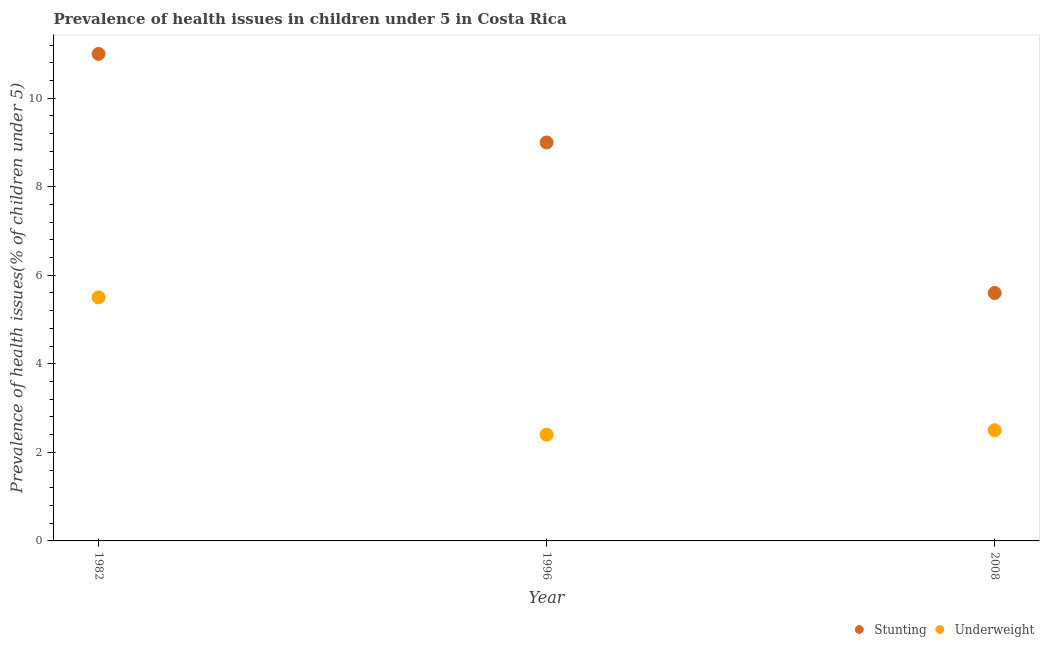How many different coloured dotlines are there?
Your response must be concise. 2. Is the number of dotlines equal to the number of legend labels?
Ensure brevity in your answer.  Yes. What is the percentage of stunted children in 2008?
Give a very brief answer. 5.6. Across all years, what is the minimum percentage of stunted children?
Make the answer very short. 5.6. What is the total percentage of stunted children in the graph?
Your response must be concise. 25.6. What is the difference between the percentage of stunted children in 1982 and that in 2008?
Make the answer very short. 5.4. What is the difference between the percentage of stunted children in 1996 and the percentage of underweight children in 2008?
Ensure brevity in your answer.  6.5. What is the average percentage of stunted children per year?
Your answer should be very brief. 8.53. In the year 2008, what is the difference between the percentage of stunted children and percentage of underweight children?
Offer a very short reply. 3.1. In how many years, is the percentage of stunted children greater than 9.2 %?
Your answer should be compact. 1. Is the difference between the percentage of underweight children in 1996 and 2008 greater than the difference between the percentage of stunted children in 1996 and 2008?
Your answer should be very brief. No. What is the difference between the highest and the lowest percentage of underweight children?
Give a very brief answer. 3.1. How many dotlines are there?
Provide a succinct answer. 2. Does the graph contain any zero values?
Provide a succinct answer. No. Does the graph contain grids?
Make the answer very short. No. How many legend labels are there?
Provide a short and direct response. 2. How are the legend labels stacked?
Your response must be concise. Horizontal. What is the title of the graph?
Your answer should be compact. Prevalence of health issues in children under 5 in Costa Rica. What is the label or title of the Y-axis?
Offer a terse response. Prevalence of health issues(% of children under 5). What is the Prevalence of health issues(% of children under 5) of Underweight in 1996?
Provide a succinct answer. 2.4. What is the Prevalence of health issues(% of children under 5) in Stunting in 2008?
Keep it short and to the point. 5.6. What is the Prevalence of health issues(% of children under 5) in Underweight in 2008?
Provide a short and direct response. 2.5. Across all years, what is the minimum Prevalence of health issues(% of children under 5) of Stunting?
Provide a short and direct response. 5.6. Across all years, what is the minimum Prevalence of health issues(% of children under 5) of Underweight?
Provide a short and direct response. 2.4. What is the total Prevalence of health issues(% of children under 5) of Stunting in the graph?
Keep it short and to the point. 25.6. What is the difference between the Prevalence of health issues(% of children under 5) of Underweight in 1982 and that in 1996?
Give a very brief answer. 3.1. What is the difference between the Prevalence of health issues(% of children under 5) in Stunting in 1982 and that in 2008?
Offer a very short reply. 5.4. What is the difference between the Prevalence of health issues(% of children under 5) in Underweight in 1982 and that in 2008?
Ensure brevity in your answer.  3. What is the difference between the Prevalence of health issues(% of children under 5) of Stunting in 1982 and the Prevalence of health issues(% of children under 5) of Underweight in 2008?
Keep it short and to the point. 8.5. What is the difference between the Prevalence of health issues(% of children under 5) in Stunting in 1996 and the Prevalence of health issues(% of children under 5) in Underweight in 2008?
Your answer should be very brief. 6.5. What is the average Prevalence of health issues(% of children under 5) in Stunting per year?
Your answer should be very brief. 8.53. What is the average Prevalence of health issues(% of children under 5) of Underweight per year?
Offer a very short reply. 3.47. In the year 1996, what is the difference between the Prevalence of health issues(% of children under 5) of Stunting and Prevalence of health issues(% of children under 5) of Underweight?
Your answer should be very brief. 6.6. What is the ratio of the Prevalence of health issues(% of children under 5) in Stunting in 1982 to that in 1996?
Give a very brief answer. 1.22. What is the ratio of the Prevalence of health issues(% of children under 5) in Underweight in 1982 to that in 1996?
Offer a terse response. 2.29. What is the ratio of the Prevalence of health issues(% of children under 5) in Stunting in 1982 to that in 2008?
Your answer should be very brief. 1.96. What is the ratio of the Prevalence of health issues(% of children under 5) of Stunting in 1996 to that in 2008?
Offer a very short reply. 1.61. What is the difference between the highest and the second highest Prevalence of health issues(% of children under 5) of Stunting?
Your answer should be compact. 2. What is the difference between the highest and the second highest Prevalence of health issues(% of children under 5) in Underweight?
Your answer should be very brief. 3. What is the difference between the highest and the lowest Prevalence of health issues(% of children under 5) in Stunting?
Offer a terse response. 5.4. 